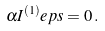<formula> <loc_0><loc_0><loc_500><loc_500>\alpha I ^ { ( 1 ) } _ { \ } e p s = 0 \, .</formula> 